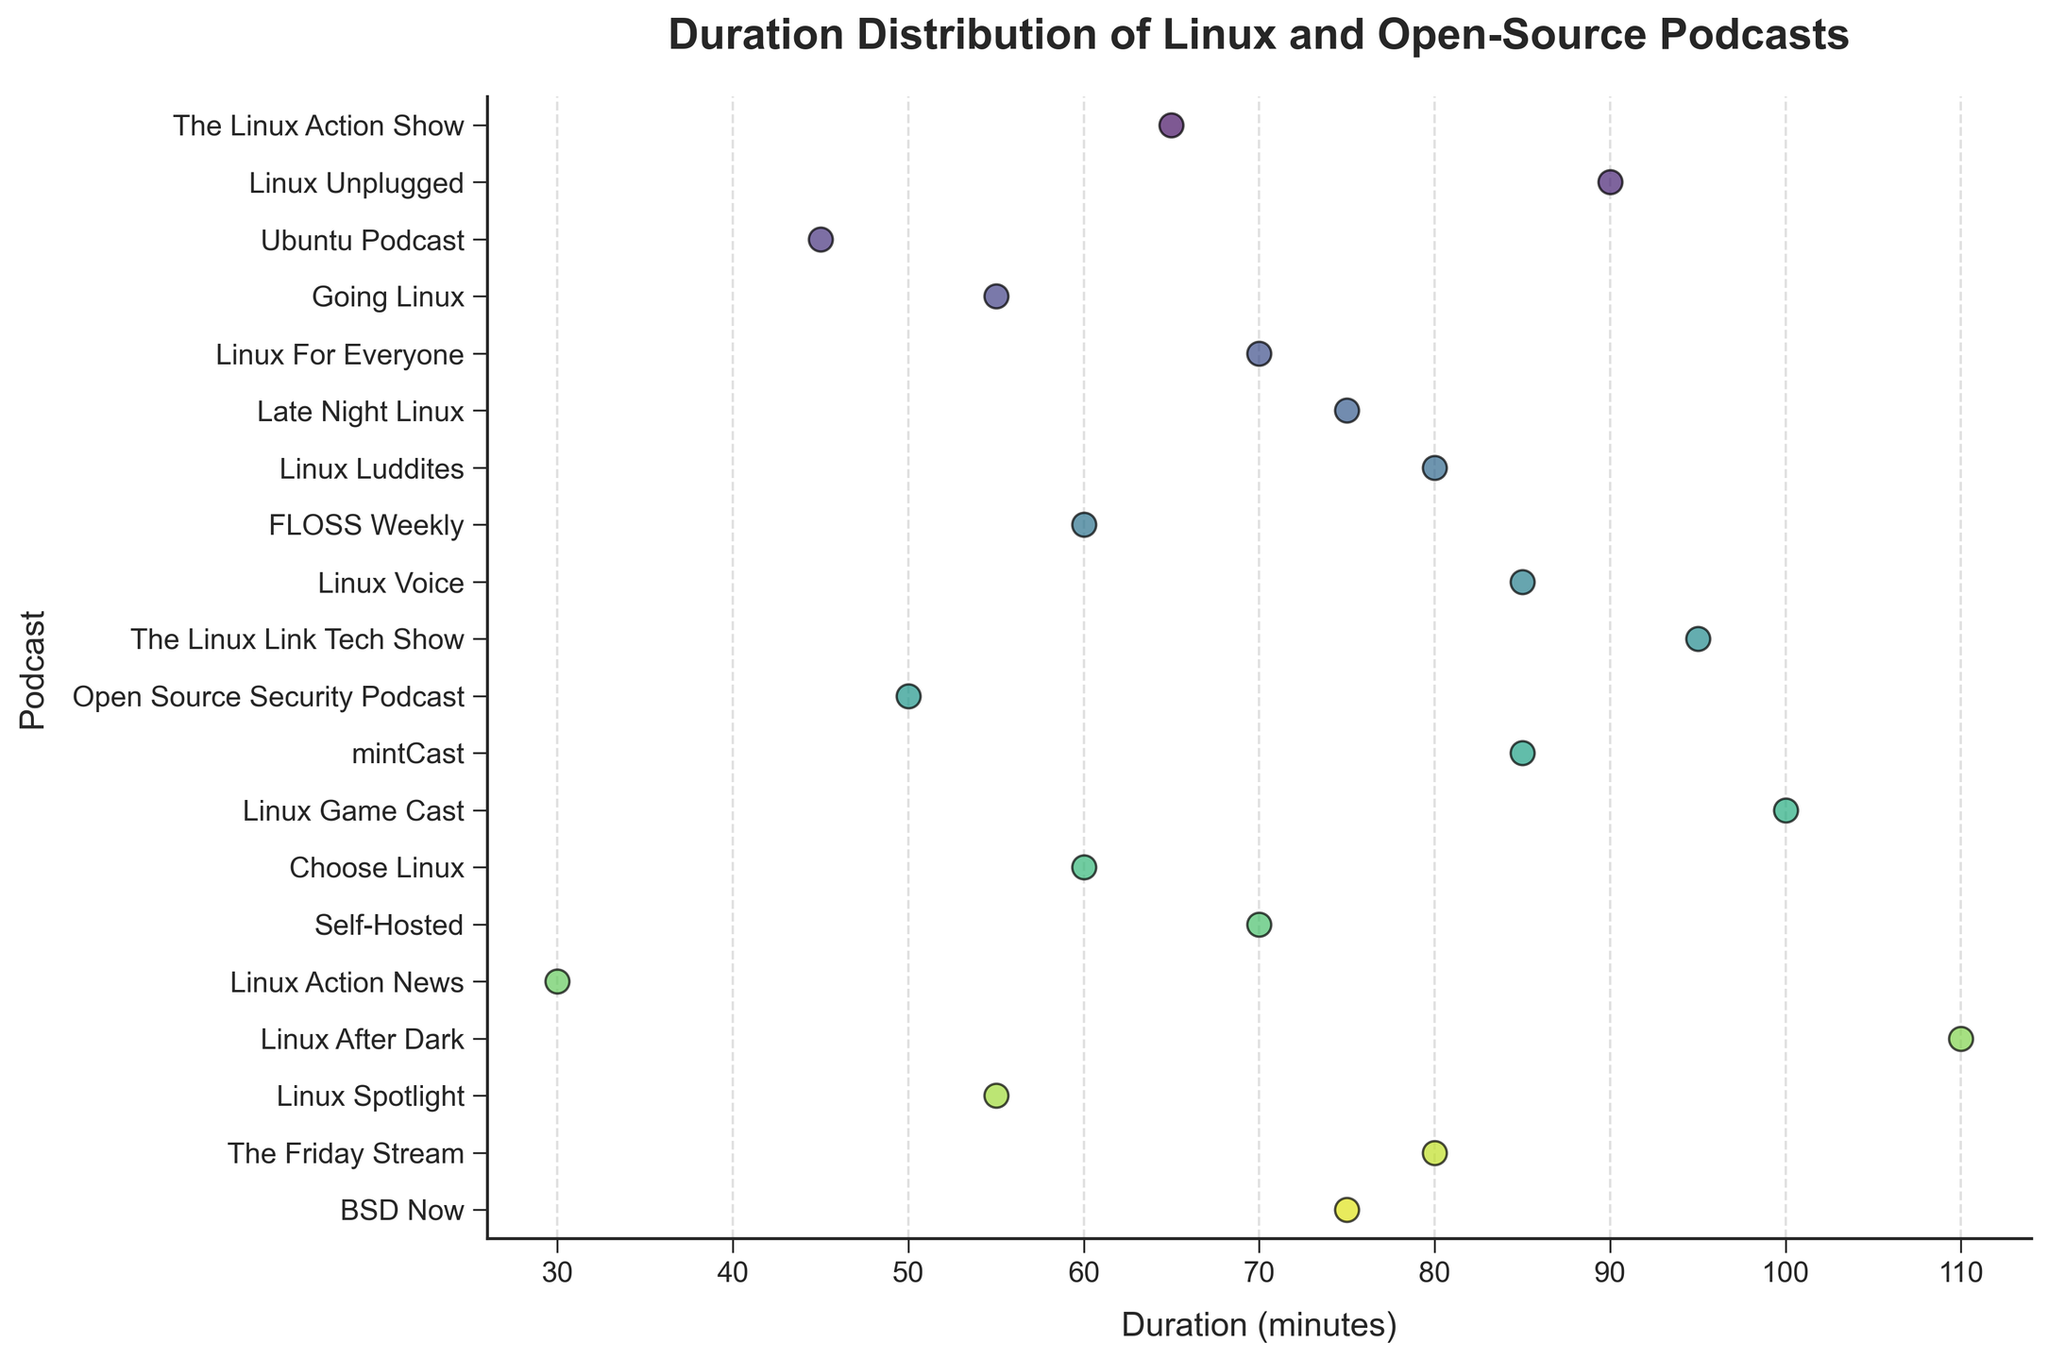What is the title of the figure? The title is displayed at the top of the figure in bold and typically provides an overarching description of what the plot represents.
Answer: Duration Distribution of Linux and Open-Source Podcasts Which podcast has the shortest episode duration? To find the shortest episode duration, look for the data point on the far left of the x-axis. The lowest value corresponds to "Linux Action News" with 30 minutes.
Answer: Linux Action News How many podcasts have episode durations of 85 minutes? Count the number of data points located at the 85-minute mark on the x-axis. There are two data points at this mark.
Answer: 2 What is the average duration of the episodes in the dataset? Add all the durations together and then divide by the number of podcasts to find the average. Sum = 65 + 90 + 45 + 55 + 70 + 75 + 80 + 60 + 85 + 95 + 50 + 85 + 100 + 60 + 70 + 30 + 110 + 55 + 80 + 75 = 1335. Average = 1335 / 20.
Answer: 66.75 minutes Which podcast has the longest episode duration? To find the longest episode duration, look for the data point on the far right of the x-axis. The highest value corresponds to "Linux After Dark" with 110 minutes.
Answer: Linux After Dark How does the duration of "BSD Now" compare to "The Linux Link Tech Show"? Locate the data points for both "BSD Now" and "The Linux Link Tech Show" and compare their positions on the x-axis. "The Linux Link Tech Show" has a duration of 95 minutes, while "BSD Now" has a duration of 75 minutes, making it shorter than "The Linux Link Tech Show".
Answer: BSD Now is shorter Are there more episodes with durations above or below the average duration? First, find the average duration (66.75 minutes). Then count the number of episodes above and below this value. 9 episodes are below 66.75 minutes, and 11 episodes are above.
Answer: More episodes are above the average What is the duration range of the episodes in "Linux Unplugged" and "Linux Game Cast"? Identify and note the durations of these podcasts. "Linux Unplugged" has a duration of 90 minutes, and "Linux Game Cast" has a duration of 100 minutes. The range is the difference between these values (100 - 90).
Answer: 10 minutes Which podcast has a similar duration to "Self-Hosted"? Find "Self-Hosted"'s duration (70 minutes) and identify another data point that is close to this value. "Linux For Everyone" also has a duration of 70 minutes.
Answer: Linux For Everyone 